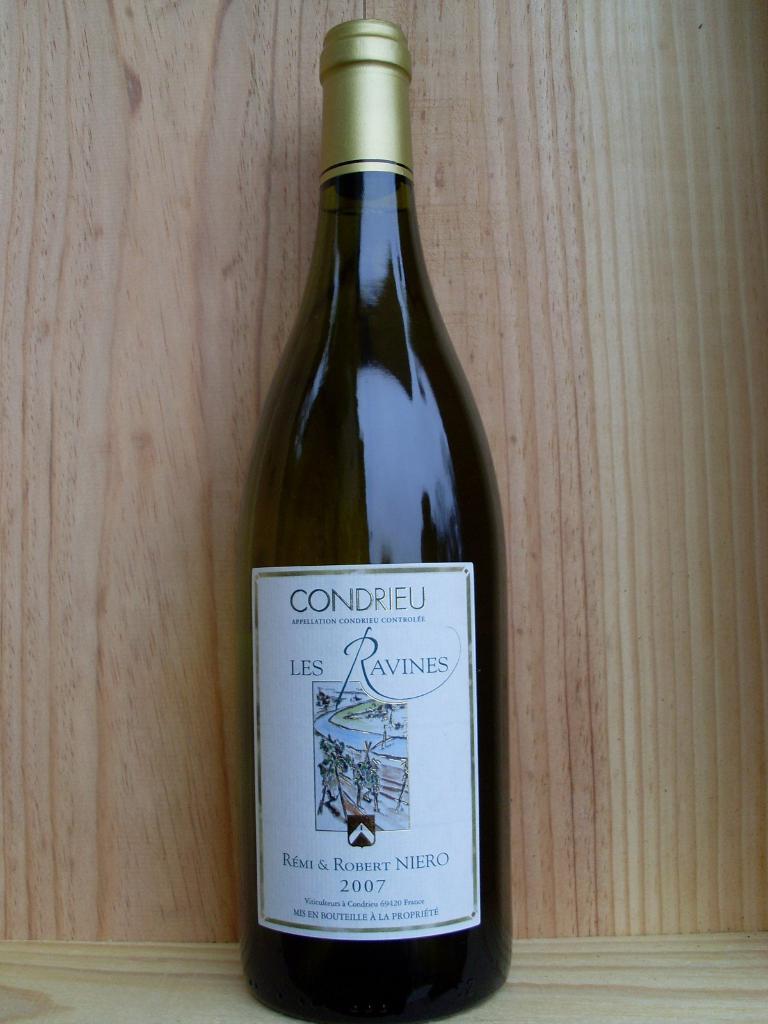In what year was this wine bottled?
Offer a very short reply. 2007. What brand is the wine pictured here?
Give a very brief answer. Condrieu. 